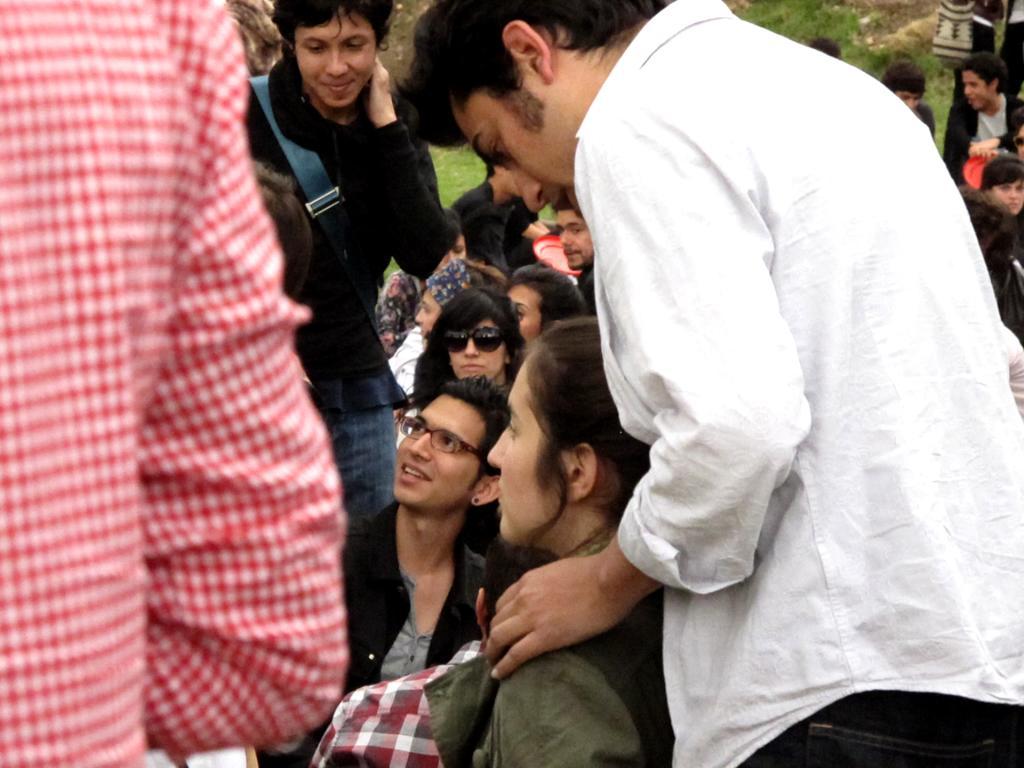Can you describe this image briefly? In this image I see number of people and I see that this woman is wearing black color shades and I see the red color things. 